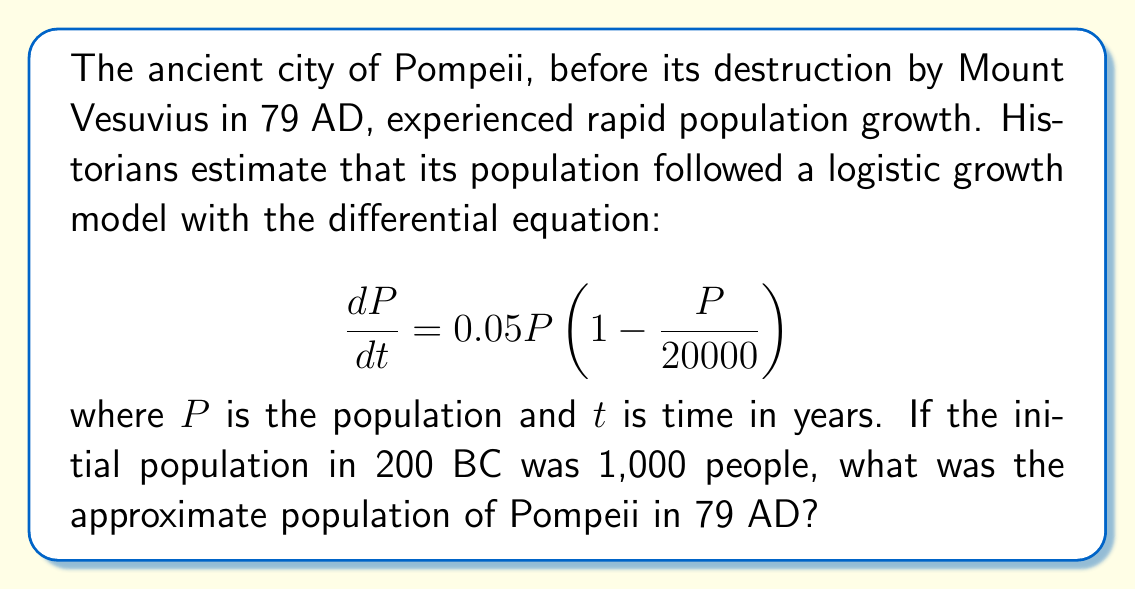Provide a solution to this math problem. To solve this problem, we need to use the logistic growth model and integrate the differential equation. Let's follow these steps:

1) The logistic growth model is given by:
   $$\frac{dP}{dt} = rP(1 - \frac{P}{K})$$
   where $r$ is the growth rate and $K$ is the carrying capacity.

2) In our case, $r = 0.05$ and $K = 20000$.

3) The solution to this differential equation is:
   $$P(t) = \frac{K}{1 + (\frac{K}{P_0} - 1)e^{-rt}}$$
   where $P_0$ is the initial population.

4) We know that $P_0 = 1000$ and we need to find $P(279)$ since 200 BC to 79 AD is 279 years.

5) Substituting our values:
   $$P(279) = \frac{20000}{1 + (\frac{20000}{1000} - 1)e^{-0.05(279)}}$$

6) Simplifying:
   $$P(279) = \frac{20000}{1 + 19e^{-13.95}}$$

7) Calculating:
   $$P(279) \approx 19,998$$

Therefore, the population of Pompeii in 79 AD was approximately 19,998 people.
Answer: 19,998 people 